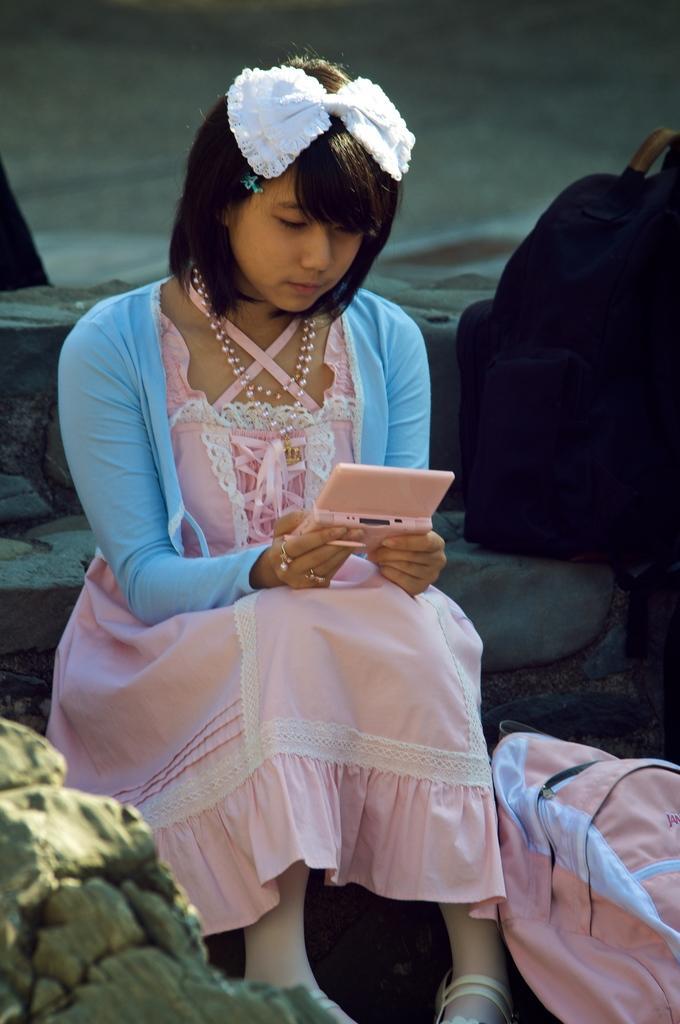Could you give a brief overview of what you see in this image? In this image I can see a woman is sitting and I can see she is holding a pink colour thing. I can see she is wearing blue jacket and pink colour dress. I can also see a white colour thing on her head and on the right side of this image I can see few bags. 